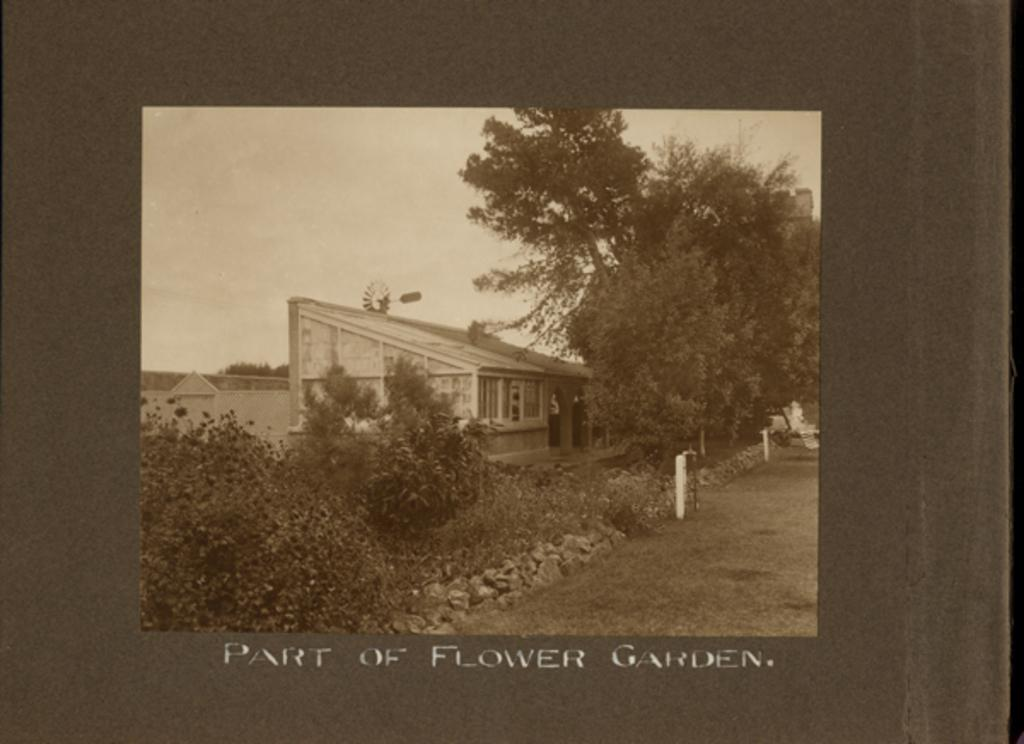What type of structure is present in the image? There is a building in the image. What type of natural elements can be seen in the image? There are stones and trees visible in the image. What safety feature is present in the image? Barrier poles are visible in the image. What part of the natural environment is visible in the image? The sky is visible in the image. What type of game is being played by the rats in the image? There are no rats present in the image, and therefore no game being played. What type of songs can be heard coming from the trees in the image? There are no songs coming from the trees in the image; it is a still image. 